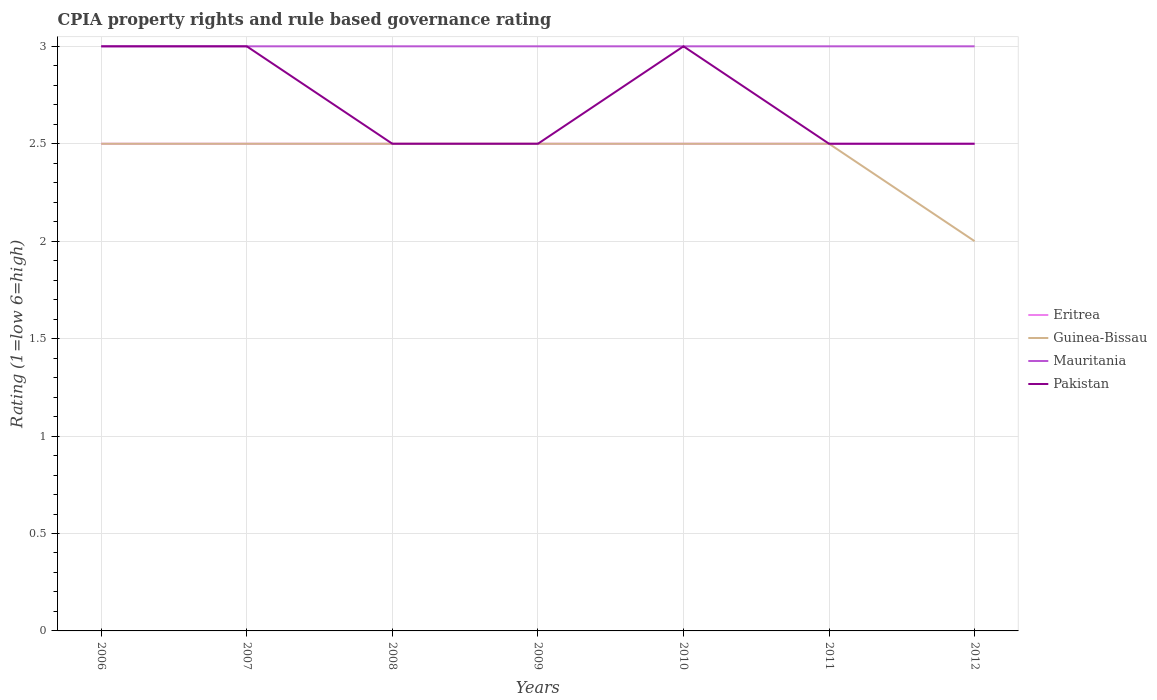How many different coloured lines are there?
Offer a terse response. 4. Across all years, what is the maximum CPIA rating in Pakistan?
Give a very brief answer. 2.5. In which year was the CPIA rating in Eritrea maximum?
Provide a short and direct response. 2006. What is the total CPIA rating in Guinea-Bissau in the graph?
Provide a short and direct response. 0. What is the difference between the highest and the second highest CPIA rating in Pakistan?
Your answer should be very brief. 0.5. How many lines are there?
Provide a short and direct response. 4. How many years are there in the graph?
Offer a terse response. 7. What is the difference between two consecutive major ticks on the Y-axis?
Give a very brief answer. 0.5. Are the values on the major ticks of Y-axis written in scientific E-notation?
Your response must be concise. No. What is the title of the graph?
Your answer should be very brief. CPIA property rights and rule based governance rating. What is the label or title of the Y-axis?
Your answer should be very brief. Rating (1=low 6=high). What is the Rating (1=low 6=high) in Eritrea in 2006?
Provide a short and direct response. 2.5. What is the Rating (1=low 6=high) in Guinea-Bissau in 2006?
Make the answer very short. 2.5. What is the Rating (1=low 6=high) in Mauritania in 2006?
Your answer should be compact. 3. What is the Rating (1=low 6=high) of Eritrea in 2007?
Keep it short and to the point. 2.5. What is the Rating (1=low 6=high) of Mauritania in 2007?
Provide a succinct answer. 3. What is the Rating (1=low 6=high) in Guinea-Bissau in 2009?
Offer a terse response. 2.5. What is the Rating (1=low 6=high) of Mauritania in 2009?
Give a very brief answer. 3. What is the Rating (1=low 6=high) of Eritrea in 2010?
Offer a terse response. 2.5. What is the Rating (1=low 6=high) of Mauritania in 2010?
Provide a short and direct response. 3. What is the Rating (1=low 6=high) in Eritrea in 2011?
Ensure brevity in your answer.  2.5. What is the Rating (1=low 6=high) of Guinea-Bissau in 2011?
Your response must be concise. 2.5. What is the Rating (1=low 6=high) of Mauritania in 2011?
Your answer should be very brief. 3. What is the Rating (1=low 6=high) in Pakistan in 2011?
Give a very brief answer. 2.5. What is the Rating (1=low 6=high) of Guinea-Bissau in 2012?
Make the answer very short. 2. What is the Rating (1=low 6=high) in Mauritania in 2012?
Your response must be concise. 3. What is the Rating (1=low 6=high) in Pakistan in 2012?
Keep it short and to the point. 2.5. Across all years, what is the maximum Rating (1=low 6=high) in Eritrea?
Your answer should be very brief. 2.5. Across all years, what is the maximum Rating (1=low 6=high) of Mauritania?
Ensure brevity in your answer.  3. Across all years, what is the maximum Rating (1=low 6=high) of Pakistan?
Give a very brief answer. 3. Across all years, what is the minimum Rating (1=low 6=high) of Eritrea?
Provide a succinct answer. 2.5. Across all years, what is the minimum Rating (1=low 6=high) of Guinea-Bissau?
Offer a terse response. 2. Across all years, what is the minimum Rating (1=low 6=high) of Mauritania?
Your answer should be very brief. 3. Across all years, what is the minimum Rating (1=low 6=high) of Pakistan?
Provide a succinct answer. 2.5. What is the total Rating (1=low 6=high) of Guinea-Bissau in the graph?
Your answer should be very brief. 17. What is the total Rating (1=low 6=high) in Mauritania in the graph?
Provide a succinct answer. 21. What is the difference between the Rating (1=low 6=high) in Eritrea in 2006 and that in 2007?
Your answer should be very brief. 0. What is the difference between the Rating (1=low 6=high) in Guinea-Bissau in 2006 and that in 2007?
Your answer should be very brief. 0. What is the difference between the Rating (1=low 6=high) of Mauritania in 2006 and that in 2007?
Offer a very short reply. 0. What is the difference between the Rating (1=low 6=high) in Mauritania in 2006 and that in 2008?
Make the answer very short. 0. What is the difference between the Rating (1=low 6=high) in Guinea-Bissau in 2006 and that in 2009?
Offer a terse response. 0. What is the difference between the Rating (1=low 6=high) of Pakistan in 2006 and that in 2009?
Provide a succinct answer. 0.5. What is the difference between the Rating (1=low 6=high) in Eritrea in 2006 and that in 2010?
Make the answer very short. 0. What is the difference between the Rating (1=low 6=high) of Guinea-Bissau in 2006 and that in 2010?
Keep it short and to the point. 0. What is the difference between the Rating (1=low 6=high) of Eritrea in 2006 and that in 2011?
Provide a succinct answer. 0. What is the difference between the Rating (1=low 6=high) in Eritrea in 2007 and that in 2008?
Provide a succinct answer. 0. What is the difference between the Rating (1=low 6=high) in Guinea-Bissau in 2007 and that in 2008?
Ensure brevity in your answer.  0. What is the difference between the Rating (1=low 6=high) of Eritrea in 2007 and that in 2009?
Offer a very short reply. 0. What is the difference between the Rating (1=low 6=high) in Mauritania in 2007 and that in 2009?
Offer a very short reply. 0. What is the difference between the Rating (1=low 6=high) in Pakistan in 2007 and that in 2009?
Offer a very short reply. 0.5. What is the difference between the Rating (1=low 6=high) in Guinea-Bissau in 2007 and that in 2011?
Your response must be concise. 0. What is the difference between the Rating (1=low 6=high) in Pakistan in 2007 and that in 2011?
Offer a terse response. 0.5. What is the difference between the Rating (1=low 6=high) in Eritrea in 2007 and that in 2012?
Offer a very short reply. 0. What is the difference between the Rating (1=low 6=high) of Guinea-Bissau in 2007 and that in 2012?
Offer a terse response. 0.5. What is the difference between the Rating (1=low 6=high) of Eritrea in 2008 and that in 2009?
Offer a terse response. 0. What is the difference between the Rating (1=low 6=high) of Mauritania in 2008 and that in 2010?
Provide a short and direct response. 0. What is the difference between the Rating (1=low 6=high) of Eritrea in 2008 and that in 2011?
Give a very brief answer. 0. What is the difference between the Rating (1=low 6=high) of Guinea-Bissau in 2008 and that in 2011?
Provide a short and direct response. 0. What is the difference between the Rating (1=low 6=high) in Pakistan in 2008 and that in 2011?
Give a very brief answer. 0. What is the difference between the Rating (1=low 6=high) of Mauritania in 2008 and that in 2012?
Offer a terse response. 0. What is the difference between the Rating (1=low 6=high) of Pakistan in 2008 and that in 2012?
Give a very brief answer. 0. What is the difference between the Rating (1=low 6=high) in Eritrea in 2009 and that in 2010?
Your answer should be compact. 0. What is the difference between the Rating (1=low 6=high) in Guinea-Bissau in 2009 and that in 2010?
Make the answer very short. 0. What is the difference between the Rating (1=low 6=high) in Guinea-Bissau in 2009 and that in 2011?
Keep it short and to the point. 0. What is the difference between the Rating (1=low 6=high) in Mauritania in 2009 and that in 2011?
Offer a terse response. 0. What is the difference between the Rating (1=low 6=high) in Pakistan in 2009 and that in 2012?
Ensure brevity in your answer.  0. What is the difference between the Rating (1=low 6=high) of Eritrea in 2010 and that in 2011?
Ensure brevity in your answer.  0. What is the difference between the Rating (1=low 6=high) in Eritrea in 2010 and that in 2012?
Your answer should be compact. 0. What is the difference between the Rating (1=low 6=high) in Guinea-Bissau in 2010 and that in 2012?
Your response must be concise. 0.5. What is the difference between the Rating (1=low 6=high) of Pakistan in 2010 and that in 2012?
Offer a terse response. 0.5. What is the difference between the Rating (1=low 6=high) in Eritrea in 2011 and that in 2012?
Offer a terse response. 0. What is the difference between the Rating (1=low 6=high) of Guinea-Bissau in 2011 and that in 2012?
Your response must be concise. 0.5. What is the difference between the Rating (1=low 6=high) in Eritrea in 2006 and the Rating (1=low 6=high) in Mauritania in 2007?
Offer a very short reply. -0.5. What is the difference between the Rating (1=low 6=high) of Eritrea in 2006 and the Rating (1=low 6=high) of Pakistan in 2007?
Your answer should be compact. -0.5. What is the difference between the Rating (1=low 6=high) in Guinea-Bissau in 2006 and the Rating (1=low 6=high) in Mauritania in 2007?
Make the answer very short. -0.5. What is the difference between the Rating (1=low 6=high) in Guinea-Bissau in 2006 and the Rating (1=low 6=high) in Pakistan in 2007?
Offer a terse response. -0.5. What is the difference between the Rating (1=low 6=high) in Eritrea in 2006 and the Rating (1=low 6=high) in Pakistan in 2008?
Provide a short and direct response. 0. What is the difference between the Rating (1=low 6=high) of Guinea-Bissau in 2006 and the Rating (1=low 6=high) of Mauritania in 2008?
Keep it short and to the point. -0.5. What is the difference between the Rating (1=low 6=high) of Mauritania in 2006 and the Rating (1=low 6=high) of Pakistan in 2008?
Your response must be concise. 0.5. What is the difference between the Rating (1=low 6=high) of Eritrea in 2006 and the Rating (1=low 6=high) of Guinea-Bissau in 2009?
Your answer should be compact. 0. What is the difference between the Rating (1=low 6=high) in Eritrea in 2006 and the Rating (1=low 6=high) in Mauritania in 2009?
Offer a very short reply. -0.5. What is the difference between the Rating (1=low 6=high) of Eritrea in 2006 and the Rating (1=low 6=high) of Mauritania in 2010?
Give a very brief answer. -0.5. What is the difference between the Rating (1=low 6=high) of Eritrea in 2006 and the Rating (1=low 6=high) of Pakistan in 2010?
Offer a very short reply. -0.5. What is the difference between the Rating (1=low 6=high) in Guinea-Bissau in 2006 and the Rating (1=low 6=high) in Pakistan in 2010?
Your answer should be compact. -0.5. What is the difference between the Rating (1=low 6=high) of Mauritania in 2006 and the Rating (1=low 6=high) of Pakistan in 2010?
Provide a succinct answer. 0. What is the difference between the Rating (1=low 6=high) in Eritrea in 2006 and the Rating (1=low 6=high) in Mauritania in 2011?
Provide a succinct answer. -0.5. What is the difference between the Rating (1=low 6=high) in Guinea-Bissau in 2006 and the Rating (1=low 6=high) in Mauritania in 2011?
Your response must be concise. -0.5. What is the difference between the Rating (1=low 6=high) of Guinea-Bissau in 2006 and the Rating (1=low 6=high) of Pakistan in 2011?
Your response must be concise. 0. What is the difference between the Rating (1=low 6=high) of Eritrea in 2006 and the Rating (1=low 6=high) of Guinea-Bissau in 2012?
Provide a succinct answer. 0.5. What is the difference between the Rating (1=low 6=high) of Eritrea in 2006 and the Rating (1=low 6=high) of Pakistan in 2012?
Provide a succinct answer. 0. What is the difference between the Rating (1=low 6=high) of Guinea-Bissau in 2006 and the Rating (1=low 6=high) of Mauritania in 2012?
Offer a very short reply. -0.5. What is the difference between the Rating (1=low 6=high) of Guinea-Bissau in 2006 and the Rating (1=low 6=high) of Pakistan in 2012?
Your response must be concise. 0. What is the difference between the Rating (1=low 6=high) of Eritrea in 2007 and the Rating (1=low 6=high) of Mauritania in 2008?
Ensure brevity in your answer.  -0.5. What is the difference between the Rating (1=low 6=high) in Guinea-Bissau in 2007 and the Rating (1=low 6=high) in Mauritania in 2008?
Provide a short and direct response. -0.5. What is the difference between the Rating (1=low 6=high) in Guinea-Bissau in 2007 and the Rating (1=low 6=high) in Mauritania in 2009?
Give a very brief answer. -0.5. What is the difference between the Rating (1=low 6=high) in Guinea-Bissau in 2007 and the Rating (1=low 6=high) in Pakistan in 2009?
Your answer should be very brief. 0. What is the difference between the Rating (1=low 6=high) of Mauritania in 2007 and the Rating (1=low 6=high) of Pakistan in 2009?
Offer a terse response. 0.5. What is the difference between the Rating (1=low 6=high) in Eritrea in 2007 and the Rating (1=low 6=high) in Guinea-Bissau in 2011?
Provide a succinct answer. 0. What is the difference between the Rating (1=low 6=high) of Eritrea in 2007 and the Rating (1=low 6=high) of Mauritania in 2011?
Offer a terse response. -0.5. What is the difference between the Rating (1=low 6=high) of Eritrea in 2007 and the Rating (1=low 6=high) of Pakistan in 2011?
Keep it short and to the point. 0. What is the difference between the Rating (1=low 6=high) of Guinea-Bissau in 2007 and the Rating (1=low 6=high) of Pakistan in 2011?
Offer a terse response. 0. What is the difference between the Rating (1=low 6=high) of Mauritania in 2007 and the Rating (1=low 6=high) of Pakistan in 2011?
Provide a short and direct response. 0.5. What is the difference between the Rating (1=low 6=high) of Eritrea in 2007 and the Rating (1=low 6=high) of Pakistan in 2012?
Ensure brevity in your answer.  0. What is the difference between the Rating (1=low 6=high) in Eritrea in 2008 and the Rating (1=low 6=high) in Guinea-Bissau in 2009?
Your answer should be very brief. 0. What is the difference between the Rating (1=low 6=high) of Eritrea in 2008 and the Rating (1=low 6=high) of Mauritania in 2009?
Ensure brevity in your answer.  -0.5. What is the difference between the Rating (1=low 6=high) in Guinea-Bissau in 2008 and the Rating (1=low 6=high) in Pakistan in 2009?
Provide a succinct answer. 0. What is the difference between the Rating (1=low 6=high) of Mauritania in 2008 and the Rating (1=low 6=high) of Pakistan in 2009?
Ensure brevity in your answer.  0.5. What is the difference between the Rating (1=low 6=high) in Eritrea in 2008 and the Rating (1=low 6=high) in Guinea-Bissau in 2010?
Offer a very short reply. 0. What is the difference between the Rating (1=low 6=high) of Eritrea in 2008 and the Rating (1=low 6=high) of Mauritania in 2010?
Keep it short and to the point. -0.5. What is the difference between the Rating (1=low 6=high) in Eritrea in 2008 and the Rating (1=low 6=high) in Pakistan in 2010?
Give a very brief answer. -0.5. What is the difference between the Rating (1=low 6=high) in Guinea-Bissau in 2008 and the Rating (1=low 6=high) in Mauritania in 2010?
Provide a succinct answer. -0.5. What is the difference between the Rating (1=low 6=high) in Eritrea in 2008 and the Rating (1=low 6=high) in Guinea-Bissau in 2011?
Give a very brief answer. 0. What is the difference between the Rating (1=low 6=high) of Eritrea in 2008 and the Rating (1=low 6=high) of Pakistan in 2011?
Provide a succinct answer. 0. What is the difference between the Rating (1=low 6=high) in Eritrea in 2008 and the Rating (1=low 6=high) in Pakistan in 2012?
Make the answer very short. 0. What is the difference between the Rating (1=low 6=high) in Guinea-Bissau in 2008 and the Rating (1=low 6=high) in Pakistan in 2012?
Your answer should be compact. 0. What is the difference between the Rating (1=low 6=high) of Mauritania in 2008 and the Rating (1=low 6=high) of Pakistan in 2012?
Offer a very short reply. 0.5. What is the difference between the Rating (1=low 6=high) of Eritrea in 2009 and the Rating (1=low 6=high) of Mauritania in 2010?
Ensure brevity in your answer.  -0.5. What is the difference between the Rating (1=low 6=high) in Eritrea in 2009 and the Rating (1=low 6=high) in Pakistan in 2010?
Offer a very short reply. -0.5. What is the difference between the Rating (1=low 6=high) in Eritrea in 2009 and the Rating (1=low 6=high) in Guinea-Bissau in 2011?
Provide a short and direct response. 0. What is the difference between the Rating (1=low 6=high) in Eritrea in 2009 and the Rating (1=low 6=high) in Mauritania in 2011?
Keep it short and to the point. -0.5. What is the difference between the Rating (1=low 6=high) in Eritrea in 2009 and the Rating (1=low 6=high) in Pakistan in 2011?
Provide a short and direct response. 0. What is the difference between the Rating (1=low 6=high) in Guinea-Bissau in 2009 and the Rating (1=low 6=high) in Mauritania in 2011?
Provide a succinct answer. -0.5. What is the difference between the Rating (1=low 6=high) of Guinea-Bissau in 2009 and the Rating (1=low 6=high) of Pakistan in 2011?
Make the answer very short. 0. What is the difference between the Rating (1=low 6=high) of Eritrea in 2009 and the Rating (1=low 6=high) of Guinea-Bissau in 2012?
Offer a terse response. 0.5. What is the difference between the Rating (1=low 6=high) of Guinea-Bissau in 2009 and the Rating (1=low 6=high) of Mauritania in 2012?
Offer a very short reply. -0.5. What is the difference between the Rating (1=low 6=high) in Eritrea in 2010 and the Rating (1=low 6=high) in Mauritania in 2011?
Make the answer very short. -0.5. What is the difference between the Rating (1=low 6=high) in Guinea-Bissau in 2010 and the Rating (1=low 6=high) in Mauritania in 2011?
Provide a short and direct response. -0.5. What is the difference between the Rating (1=low 6=high) of Guinea-Bissau in 2010 and the Rating (1=low 6=high) of Pakistan in 2011?
Your answer should be very brief. 0. What is the difference between the Rating (1=low 6=high) of Eritrea in 2010 and the Rating (1=low 6=high) of Pakistan in 2012?
Give a very brief answer. 0. What is the difference between the Rating (1=low 6=high) in Mauritania in 2010 and the Rating (1=low 6=high) in Pakistan in 2012?
Provide a short and direct response. 0.5. What is the difference between the Rating (1=low 6=high) in Eritrea in 2011 and the Rating (1=low 6=high) in Guinea-Bissau in 2012?
Ensure brevity in your answer.  0.5. What is the difference between the Rating (1=low 6=high) in Eritrea in 2011 and the Rating (1=low 6=high) in Pakistan in 2012?
Offer a very short reply. 0. What is the difference between the Rating (1=low 6=high) in Guinea-Bissau in 2011 and the Rating (1=low 6=high) in Pakistan in 2012?
Offer a terse response. 0. What is the average Rating (1=low 6=high) in Eritrea per year?
Your answer should be very brief. 2.5. What is the average Rating (1=low 6=high) in Guinea-Bissau per year?
Your answer should be very brief. 2.43. What is the average Rating (1=low 6=high) in Pakistan per year?
Your answer should be compact. 2.71. In the year 2006, what is the difference between the Rating (1=low 6=high) of Eritrea and Rating (1=low 6=high) of Guinea-Bissau?
Make the answer very short. 0. In the year 2006, what is the difference between the Rating (1=low 6=high) of Guinea-Bissau and Rating (1=low 6=high) of Mauritania?
Your response must be concise. -0.5. In the year 2006, what is the difference between the Rating (1=low 6=high) of Guinea-Bissau and Rating (1=low 6=high) of Pakistan?
Your response must be concise. -0.5. In the year 2006, what is the difference between the Rating (1=low 6=high) in Mauritania and Rating (1=low 6=high) in Pakistan?
Your response must be concise. 0. In the year 2007, what is the difference between the Rating (1=low 6=high) in Eritrea and Rating (1=low 6=high) in Guinea-Bissau?
Give a very brief answer. 0. In the year 2007, what is the difference between the Rating (1=low 6=high) in Eritrea and Rating (1=low 6=high) in Mauritania?
Offer a terse response. -0.5. In the year 2007, what is the difference between the Rating (1=low 6=high) in Guinea-Bissau and Rating (1=low 6=high) in Pakistan?
Make the answer very short. -0.5. In the year 2008, what is the difference between the Rating (1=low 6=high) of Eritrea and Rating (1=low 6=high) of Pakistan?
Make the answer very short. 0. In the year 2008, what is the difference between the Rating (1=low 6=high) of Guinea-Bissau and Rating (1=low 6=high) of Mauritania?
Offer a terse response. -0.5. In the year 2008, what is the difference between the Rating (1=low 6=high) in Guinea-Bissau and Rating (1=low 6=high) in Pakistan?
Your answer should be compact. 0. In the year 2008, what is the difference between the Rating (1=low 6=high) in Mauritania and Rating (1=low 6=high) in Pakistan?
Provide a short and direct response. 0.5. In the year 2009, what is the difference between the Rating (1=low 6=high) in Eritrea and Rating (1=low 6=high) in Guinea-Bissau?
Ensure brevity in your answer.  0. In the year 2009, what is the difference between the Rating (1=low 6=high) of Guinea-Bissau and Rating (1=low 6=high) of Pakistan?
Your response must be concise. 0. In the year 2009, what is the difference between the Rating (1=low 6=high) of Mauritania and Rating (1=low 6=high) of Pakistan?
Provide a succinct answer. 0.5. In the year 2010, what is the difference between the Rating (1=low 6=high) in Eritrea and Rating (1=low 6=high) in Mauritania?
Make the answer very short. -0.5. In the year 2010, what is the difference between the Rating (1=low 6=high) of Eritrea and Rating (1=low 6=high) of Pakistan?
Your response must be concise. -0.5. In the year 2010, what is the difference between the Rating (1=low 6=high) in Guinea-Bissau and Rating (1=low 6=high) in Pakistan?
Make the answer very short. -0.5. In the year 2010, what is the difference between the Rating (1=low 6=high) of Mauritania and Rating (1=low 6=high) of Pakistan?
Provide a succinct answer. 0. In the year 2011, what is the difference between the Rating (1=low 6=high) of Eritrea and Rating (1=low 6=high) of Guinea-Bissau?
Offer a terse response. 0. In the year 2011, what is the difference between the Rating (1=low 6=high) in Eritrea and Rating (1=low 6=high) in Pakistan?
Provide a short and direct response. 0. In the year 2011, what is the difference between the Rating (1=low 6=high) in Guinea-Bissau and Rating (1=low 6=high) in Mauritania?
Keep it short and to the point. -0.5. In the year 2011, what is the difference between the Rating (1=low 6=high) in Mauritania and Rating (1=low 6=high) in Pakistan?
Your answer should be very brief. 0.5. In the year 2012, what is the difference between the Rating (1=low 6=high) of Eritrea and Rating (1=low 6=high) of Mauritania?
Provide a short and direct response. -0.5. In the year 2012, what is the difference between the Rating (1=low 6=high) in Eritrea and Rating (1=low 6=high) in Pakistan?
Offer a terse response. 0. In the year 2012, what is the difference between the Rating (1=low 6=high) in Mauritania and Rating (1=low 6=high) in Pakistan?
Offer a terse response. 0.5. What is the ratio of the Rating (1=low 6=high) in Eritrea in 2006 to that in 2007?
Your answer should be compact. 1. What is the ratio of the Rating (1=low 6=high) in Mauritania in 2006 to that in 2007?
Provide a succinct answer. 1. What is the ratio of the Rating (1=low 6=high) of Pakistan in 2006 to that in 2007?
Your answer should be very brief. 1. What is the ratio of the Rating (1=low 6=high) of Guinea-Bissau in 2006 to that in 2008?
Keep it short and to the point. 1. What is the ratio of the Rating (1=low 6=high) in Mauritania in 2006 to that in 2008?
Provide a short and direct response. 1. What is the ratio of the Rating (1=low 6=high) in Pakistan in 2006 to that in 2008?
Make the answer very short. 1.2. What is the ratio of the Rating (1=low 6=high) of Eritrea in 2006 to that in 2009?
Offer a very short reply. 1. What is the ratio of the Rating (1=low 6=high) in Guinea-Bissau in 2006 to that in 2009?
Your answer should be compact. 1. What is the ratio of the Rating (1=low 6=high) of Mauritania in 2006 to that in 2009?
Your answer should be compact. 1. What is the ratio of the Rating (1=low 6=high) in Pakistan in 2006 to that in 2009?
Provide a succinct answer. 1.2. What is the ratio of the Rating (1=low 6=high) in Guinea-Bissau in 2006 to that in 2010?
Your answer should be compact. 1. What is the ratio of the Rating (1=low 6=high) in Mauritania in 2006 to that in 2010?
Offer a terse response. 1. What is the ratio of the Rating (1=low 6=high) in Guinea-Bissau in 2006 to that in 2011?
Your answer should be very brief. 1. What is the ratio of the Rating (1=low 6=high) of Eritrea in 2006 to that in 2012?
Your response must be concise. 1. What is the ratio of the Rating (1=low 6=high) of Eritrea in 2007 to that in 2008?
Your answer should be compact. 1. What is the ratio of the Rating (1=low 6=high) of Mauritania in 2007 to that in 2008?
Make the answer very short. 1. What is the ratio of the Rating (1=low 6=high) in Eritrea in 2007 to that in 2010?
Keep it short and to the point. 1. What is the ratio of the Rating (1=low 6=high) of Mauritania in 2007 to that in 2010?
Your response must be concise. 1. What is the ratio of the Rating (1=low 6=high) of Pakistan in 2007 to that in 2010?
Ensure brevity in your answer.  1. What is the ratio of the Rating (1=low 6=high) in Eritrea in 2007 to that in 2011?
Provide a succinct answer. 1. What is the ratio of the Rating (1=low 6=high) of Guinea-Bissau in 2007 to that in 2011?
Your response must be concise. 1. What is the ratio of the Rating (1=low 6=high) of Mauritania in 2007 to that in 2011?
Your answer should be compact. 1. What is the ratio of the Rating (1=low 6=high) in Guinea-Bissau in 2007 to that in 2012?
Give a very brief answer. 1.25. What is the ratio of the Rating (1=low 6=high) of Mauritania in 2007 to that in 2012?
Keep it short and to the point. 1. What is the ratio of the Rating (1=low 6=high) of Pakistan in 2007 to that in 2012?
Keep it short and to the point. 1.2. What is the ratio of the Rating (1=low 6=high) of Guinea-Bissau in 2008 to that in 2009?
Make the answer very short. 1. What is the ratio of the Rating (1=low 6=high) in Pakistan in 2008 to that in 2009?
Keep it short and to the point. 1. What is the ratio of the Rating (1=low 6=high) of Pakistan in 2008 to that in 2010?
Provide a succinct answer. 0.83. What is the ratio of the Rating (1=low 6=high) of Guinea-Bissau in 2008 to that in 2011?
Provide a succinct answer. 1. What is the ratio of the Rating (1=low 6=high) in Eritrea in 2008 to that in 2012?
Give a very brief answer. 1. What is the ratio of the Rating (1=low 6=high) in Guinea-Bissau in 2008 to that in 2012?
Give a very brief answer. 1.25. What is the ratio of the Rating (1=low 6=high) in Pakistan in 2008 to that in 2012?
Ensure brevity in your answer.  1. What is the ratio of the Rating (1=low 6=high) of Guinea-Bissau in 2009 to that in 2010?
Make the answer very short. 1. What is the ratio of the Rating (1=low 6=high) in Pakistan in 2009 to that in 2010?
Offer a terse response. 0.83. What is the ratio of the Rating (1=low 6=high) in Eritrea in 2009 to that in 2011?
Your answer should be compact. 1. What is the ratio of the Rating (1=low 6=high) in Mauritania in 2009 to that in 2011?
Make the answer very short. 1. What is the ratio of the Rating (1=low 6=high) in Guinea-Bissau in 2009 to that in 2012?
Ensure brevity in your answer.  1.25. What is the ratio of the Rating (1=low 6=high) of Mauritania in 2009 to that in 2012?
Offer a terse response. 1. What is the ratio of the Rating (1=low 6=high) in Mauritania in 2010 to that in 2011?
Your response must be concise. 1. What is the ratio of the Rating (1=low 6=high) of Eritrea in 2010 to that in 2012?
Ensure brevity in your answer.  1. What is the ratio of the Rating (1=low 6=high) in Guinea-Bissau in 2010 to that in 2012?
Make the answer very short. 1.25. What is the ratio of the Rating (1=low 6=high) of Mauritania in 2010 to that in 2012?
Keep it short and to the point. 1. What is the ratio of the Rating (1=low 6=high) of Eritrea in 2011 to that in 2012?
Keep it short and to the point. 1. What is the ratio of the Rating (1=low 6=high) in Guinea-Bissau in 2011 to that in 2012?
Keep it short and to the point. 1.25. What is the ratio of the Rating (1=low 6=high) of Mauritania in 2011 to that in 2012?
Your response must be concise. 1. What is the difference between the highest and the second highest Rating (1=low 6=high) of Eritrea?
Your answer should be very brief. 0. What is the difference between the highest and the second highest Rating (1=low 6=high) in Mauritania?
Offer a terse response. 0. What is the difference between the highest and the second highest Rating (1=low 6=high) of Pakistan?
Offer a terse response. 0. What is the difference between the highest and the lowest Rating (1=low 6=high) of Guinea-Bissau?
Your response must be concise. 0.5. 